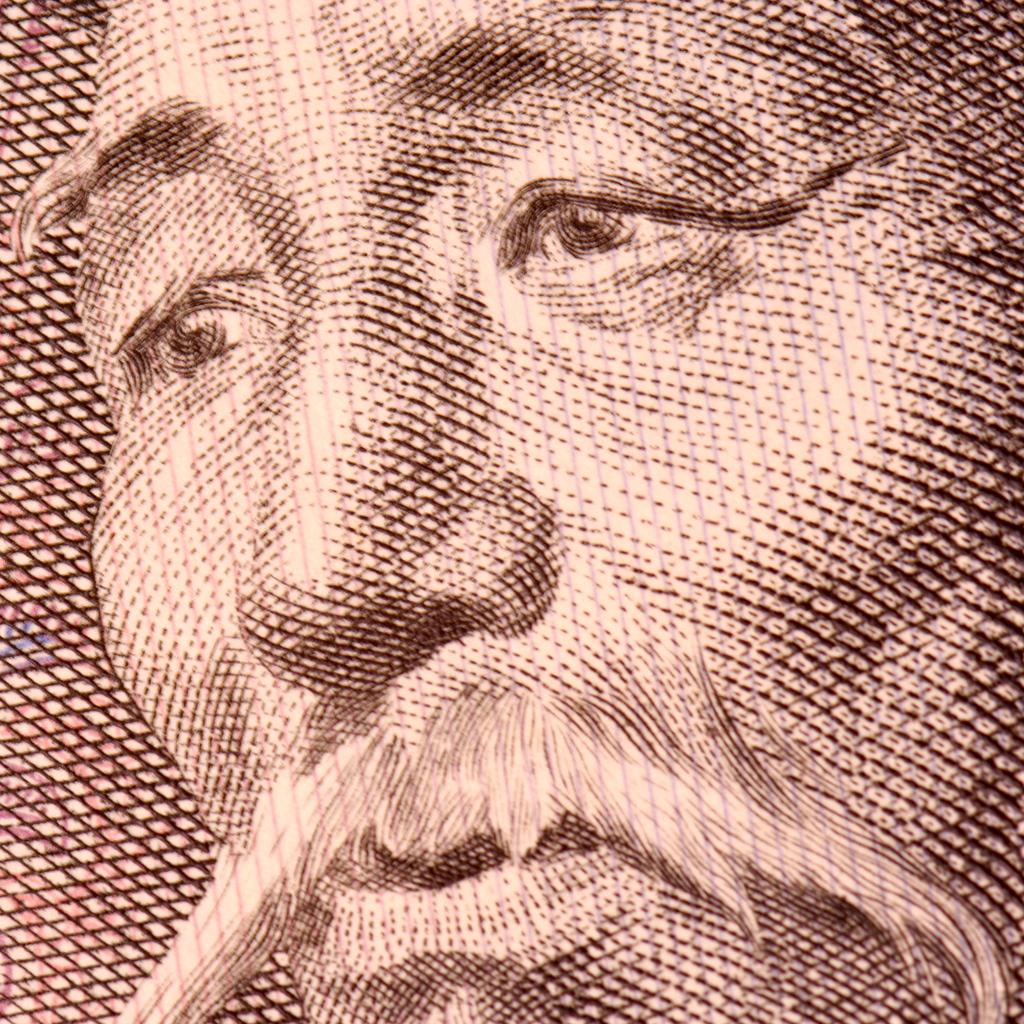What type of artwork is shown in the image? The image is a painting. What subject matter is depicted in the painting? The painting depicts a person's face. How many family members are present in the painting? There is no indication of family members in the painting, as it only depicts a person's face. Can you describe the changes in the person's facial expression throughout the painting? There is no indication of changes in the person's facial expression, as the painting only shows a single moment in time. 